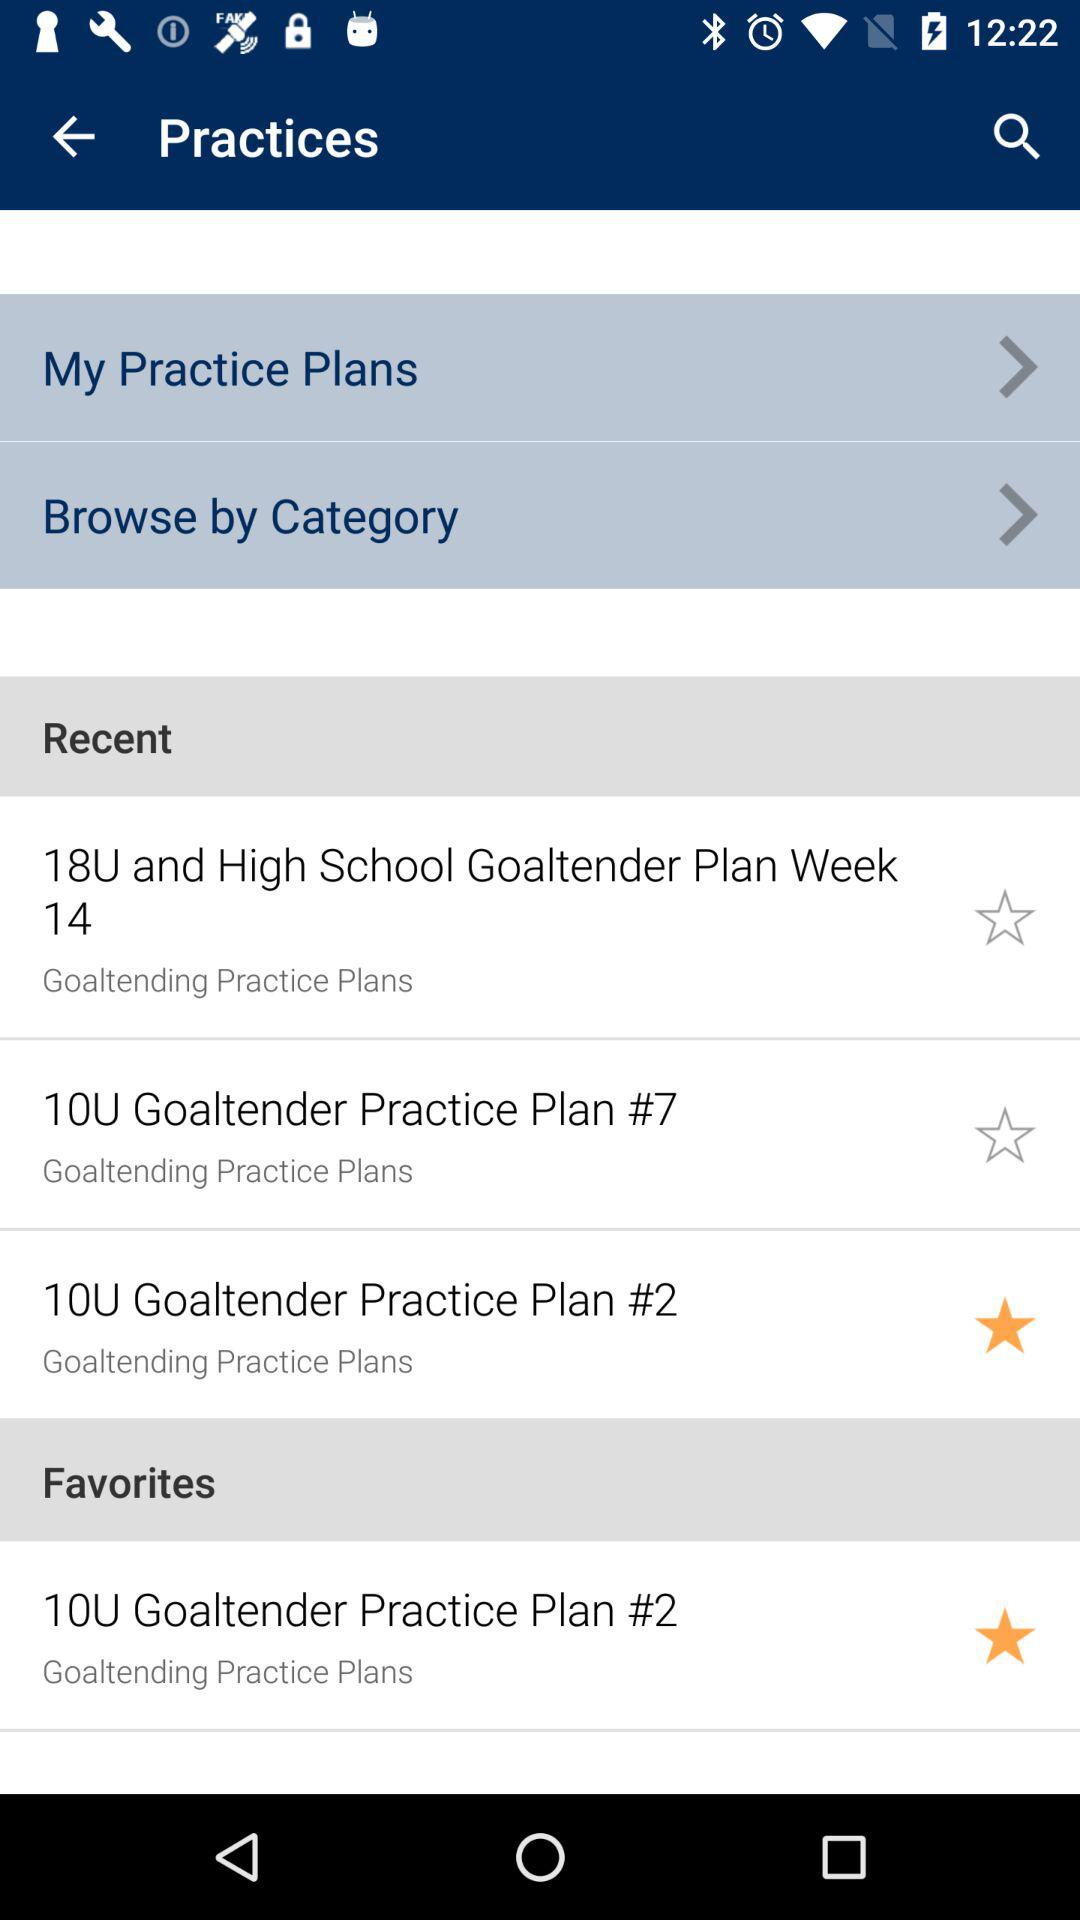How many practice plans are currently in the favorites section?
Answer the question using a single word or phrase. 1 